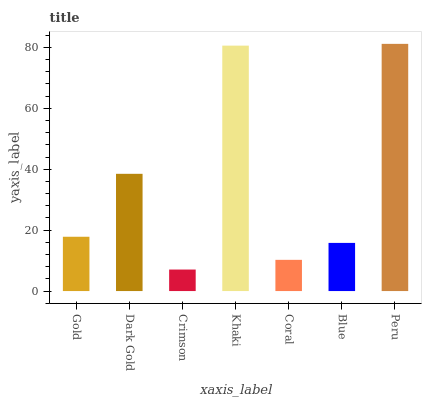Is Crimson the minimum?
Answer yes or no. Yes. Is Peru the maximum?
Answer yes or no. Yes. Is Dark Gold the minimum?
Answer yes or no. No. Is Dark Gold the maximum?
Answer yes or no. No. Is Dark Gold greater than Gold?
Answer yes or no. Yes. Is Gold less than Dark Gold?
Answer yes or no. Yes. Is Gold greater than Dark Gold?
Answer yes or no. No. Is Dark Gold less than Gold?
Answer yes or no. No. Is Gold the high median?
Answer yes or no. Yes. Is Gold the low median?
Answer yes or no. Yes. Is Coral the high median?
Answer yes or no. No. Is Peru the low median?
Answer yes or no. No. 